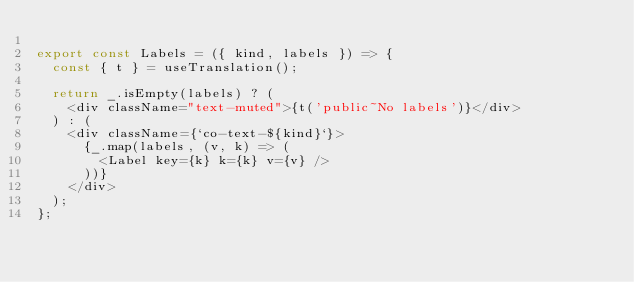Convert code to text. <code><loc_0><loc_0><loc_500><loc_500><_TypeScript_>
export const Labels = ({ kind, labels }) => {
  const { t } = useTranslation();

  return _.isEmpty(labels) ? (
    <div className="text-muted">{t('public~No labels')}</div>
  ) : (
    <div className={`co-text-${kind}`}>
      {_.map(labels, (v, k) => (
        <Label key={k} k={k} v={v} />
      ))}
    </div>
  );
};
</code> 